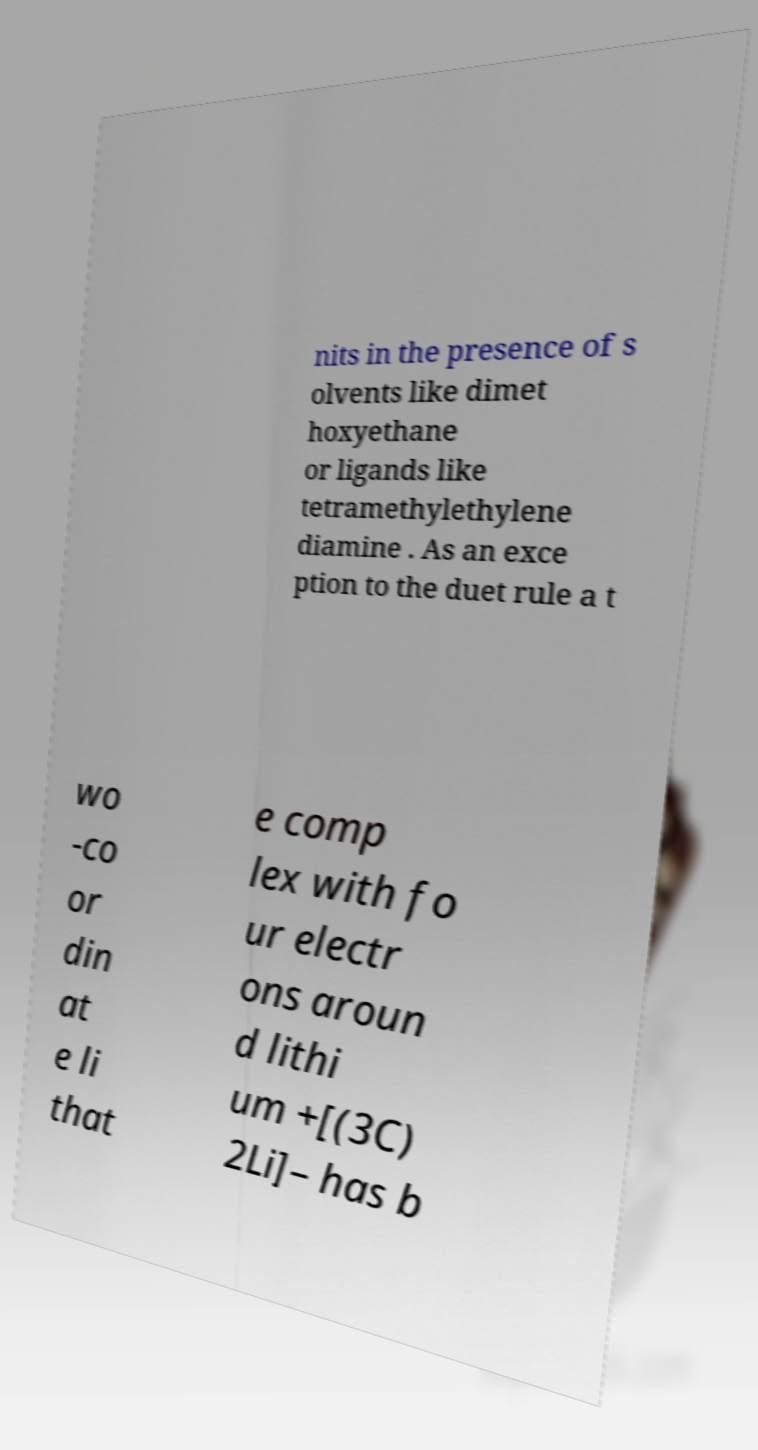There's text embedded in this image that I need extracted. Can you transcribe it verbatim? nits in the presence of s olvents like dimet hoxyethane or ligands like tetramethylethylene diamine . As an exce ption to the duet rule a t wo -co or din at e li that e comp lex with fo ur electr ons aroun d lithi um +[(3C) 2Li]– has b 